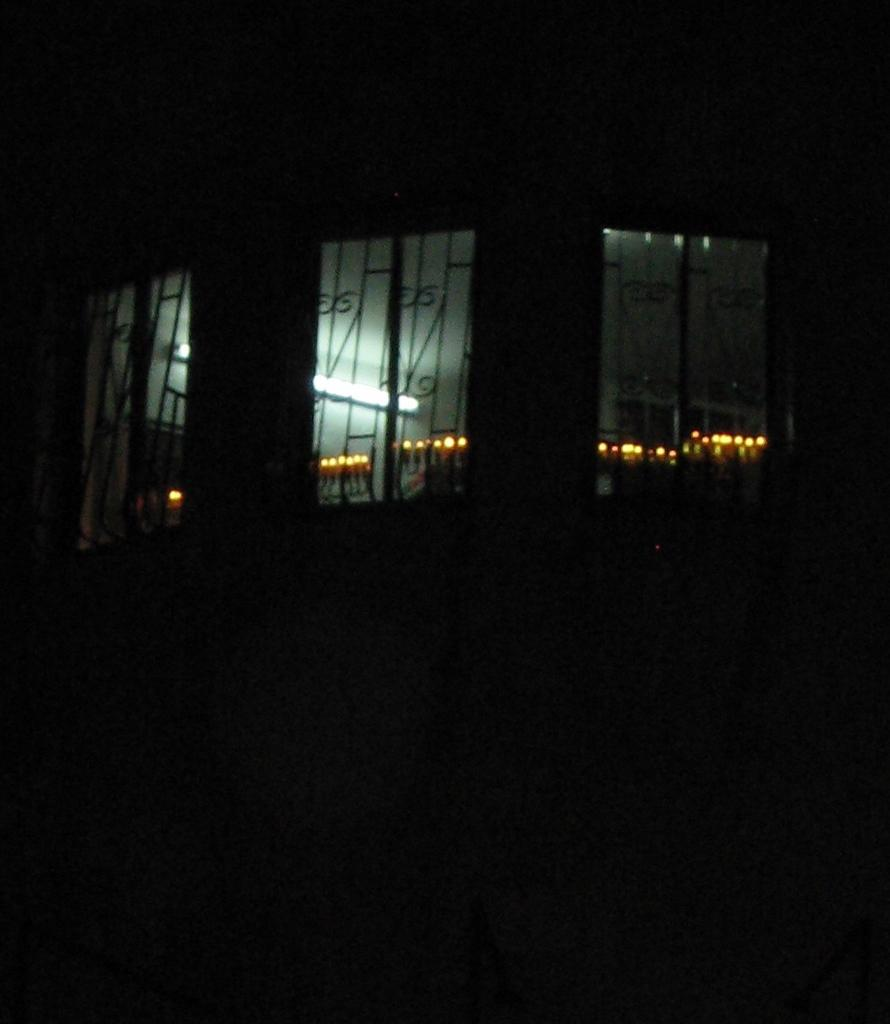What is the overall lighting condition of the image? The image is dark. What can be seen in the center of the image? There are three windows visible in the center of the image. What is visible through the windows? Lights and a wall are visible through the windows. What type of creature can be seen guarding the prison in the image? There is no prison or creature present in the image; it only features three windows with lights and a wall visible through them. 